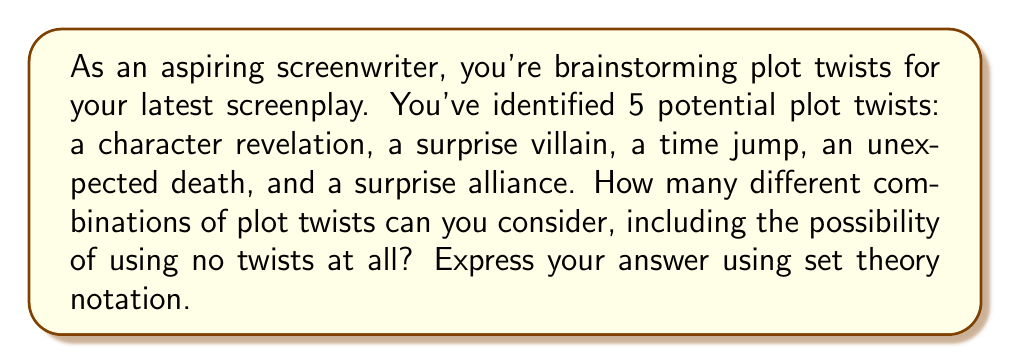Can you answer this question? To solve this problem, we need to consider the power set of the set of plot twists. The power set is the set of all possible subsets of a given set, including the empty set and the set itself.

Let's define our set of plot twists:
$$ A = \{\text{character revelation, surprise villain, time jump, unexpected death, surprise alliance}\} $$

The number of elements in set $A$ is 5.

To find the number of elements in the power set of $A$, we use the formula:

$$ |P(A)| = 2^n $$

Where $n$ is the number of elements in the original set $A$.

In this case:
$$ |P(A)| = 2^5 = 32 $$

This means there are 32 different combinations of plot twists, including:
1. The empty set (no plot twists)
2. Each individual plot twist alone (5 combinations)
3. Various combinations of two, three, or four plot twists
4. All five plot twists together

To express this using set theory notation, we can write:

$$ |P(A)| = 2^{|A|} = 2^5 = 32 $$

This notation reads as "the cardinality (number of elements) of the power set of $A$ is equal to 2 raised to the power of the cardinality of $A$, which is 5, resulting in 32."
Answer: $$ |P(A)| = 2^{|A|} = 2^5 = 32 $$ 